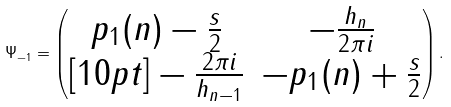<formula> <loc_0><loc_0><loc_500><loc_500>\Psi _ { - 1 } = \begin{pmatrix} p _ { 1 } ( n ) - \frac { s } { 2 } & - \frac { h _ { n } } { 2 \pi i } \\ [ 1 0 p t ] - \frac { 2 \pi i } { h _ { n - 1 } } & - p _ { 1 } ( n ) + \frac { s } { 2 } \end{pmatrix} .</formula> 